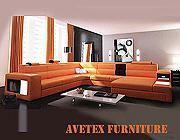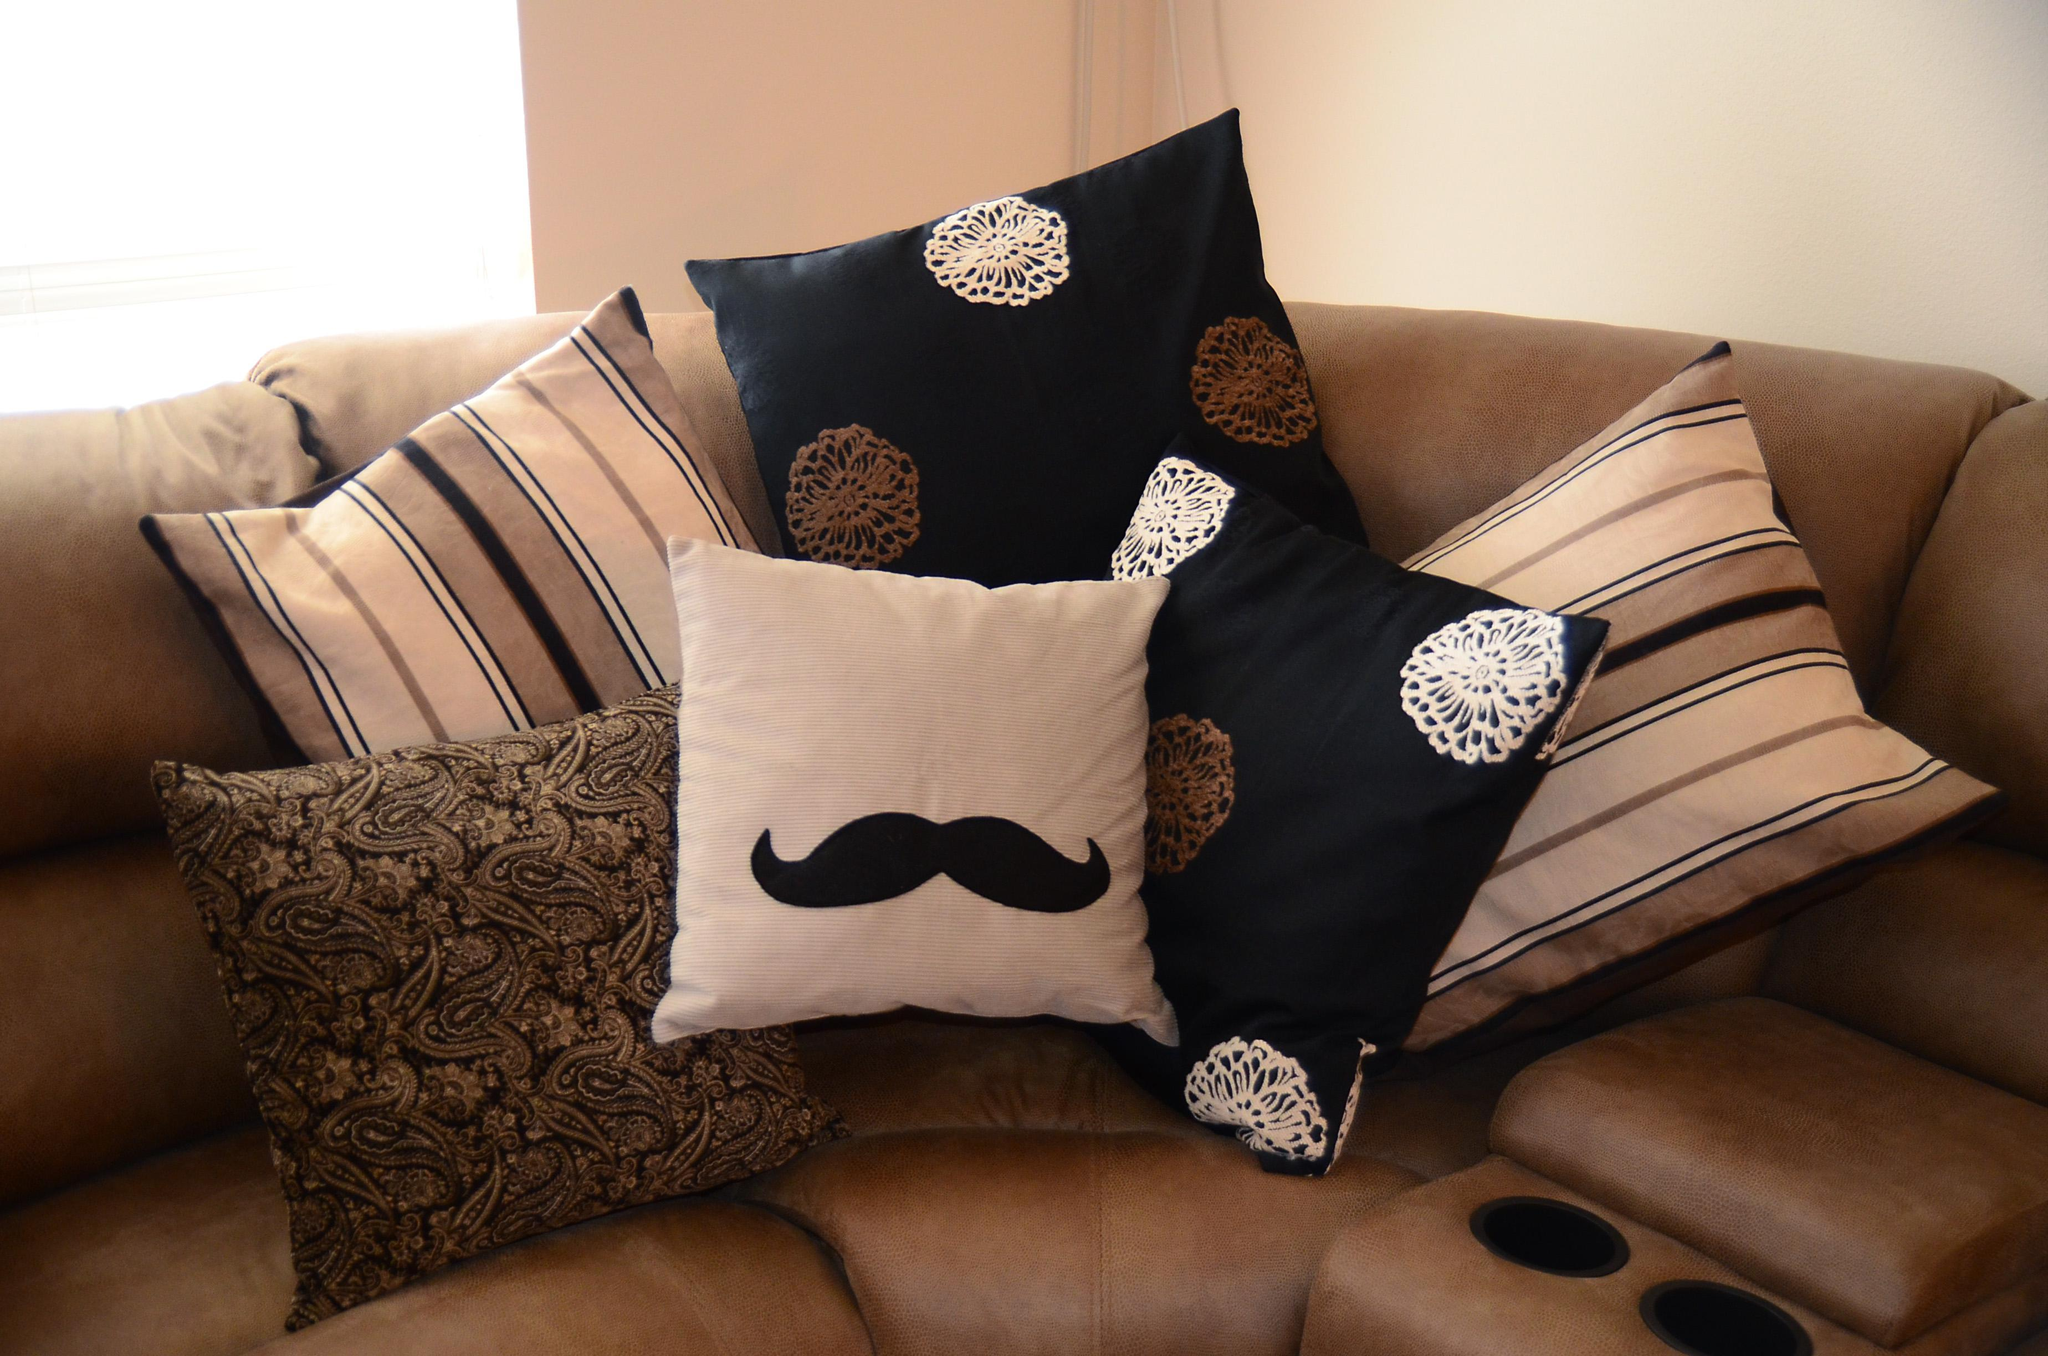The first image is the image on the left, the second image is the image on the right. For the images shown, is this caption "One room includes an orange sectional couch that forms a corner, in front of hanging orange drapes." true? Answer yes or no. Yes. The first image is the image on the left, the second image is the image on the right. Considering the images on both sides, is "The pillows on one of the images are sitting on a brown couch." valid? Answer yes or no. Yes. 